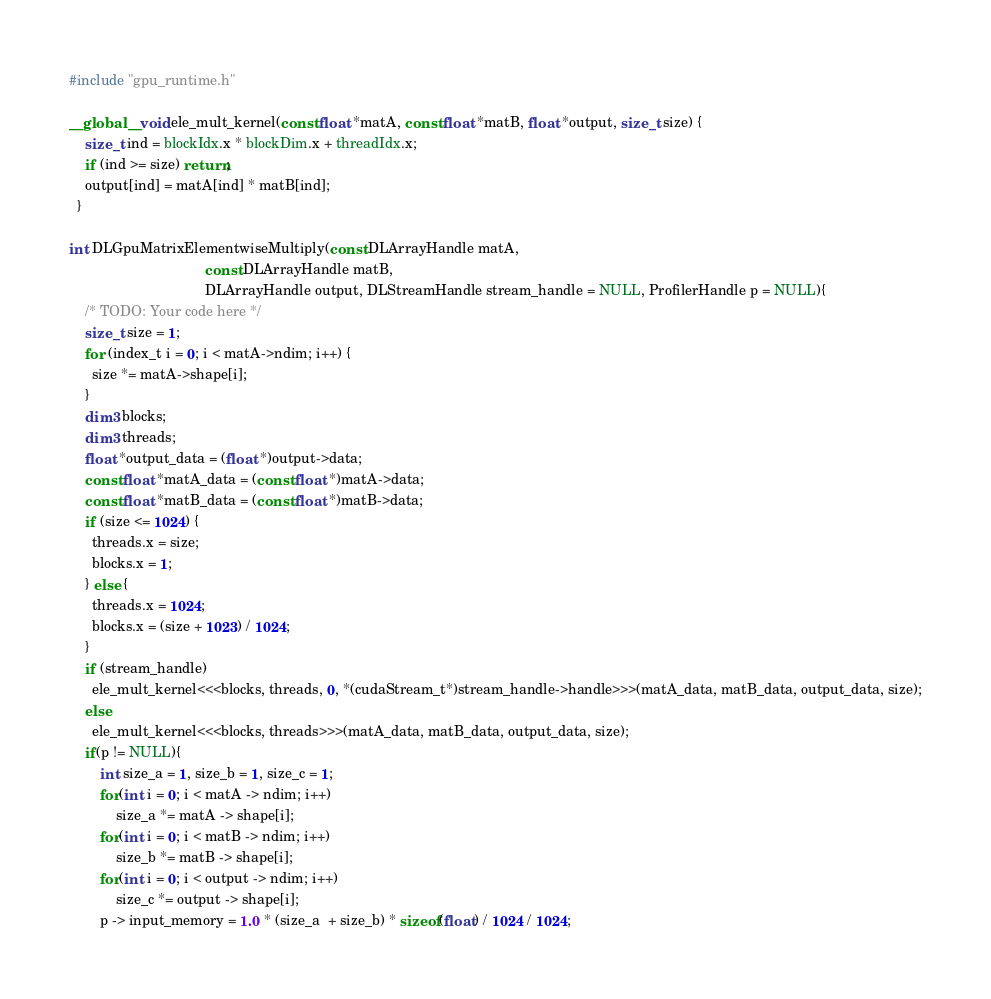<code> <loc_0><loc_0><loc_500><loc_500><_Cuda_>#include "gpu_runtime.h"

__global__ void ele_mult_kernel(const float *matA, const float *matB, float *output, size_t size) {
    size_t ind = blockIdx.x * blockDim.x + threadIdx.x;
    if (ind >= size) return;
    output[ind] = matA[ind] * matB[ind];
  }
  
int DLGpuMatrixElementwiseMultiply(const DLArrayHandle matA,
                                   const DLArrayHandle matB,
                                   DLArrayHandle output, DLStreamHandle stream_handle = NULL, ProfilerHandle p = NULL){
    /* TODO: Your code here */
    size_t size = 1;
    for (index_t i = 0; i < matA->ndim; i++) {
      size *= matA->shape[i];
    }
    dim3 blocks;
    dim3 threads;
    float *output_data = (float *)output->data;
    const float *matA_data = (const float *)matA->data;
    const float *matB_data = (const float *)matB->data;
    if (size <= 1024) {
      threads.x = size;
      blocks.x = 1;
    } else {
      threads.x = 1024;
      blocks.x = (size + 1023) / 1024;
    }
    if (stream_handle)
      ele_mult_kernel<<<blocks, threads, 0, *(cudaStream_t*)stream_handle->handle>>>(matA_data, matB_data, output_data, size);
    else
      ele_mult_kernel<<<blocks, threads>>>(matA_data, matB_data, output_data, size);
    if(p != NULL){
        int size_a = 1, size_b = 1, size_c = 1;
        for(int i = 0; i < matA -> ndim; i++)
            size_a *= matA -> shape[i];
        for(int i = 0; i < matB -> ndim; i++)
            size_b *= matB -> shape[i];
        for(int i = 0; i < output -> ndim; i++)
            size_c *= output -> shape[i];
        p -> input_memory = 1.0 * (size_a  + size_b) * sizeof(float) / 1024 / 1024;</code> 